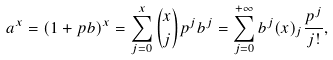Convert formula to latex. <formula><loc_0><loc_0><loc_500><loc_500>a ^ { x } = ( 1 + p b ) ^ { x } = \sum _ { j = 0 } ^ { x } { x \choose j } p ^ { j } b ^ { j } = \sum _ { j = 0 } ^ { + \infty } b ^ { j } ( x ) _ { j } \frac { p ^ { j } } { j ! } ,</formula> 